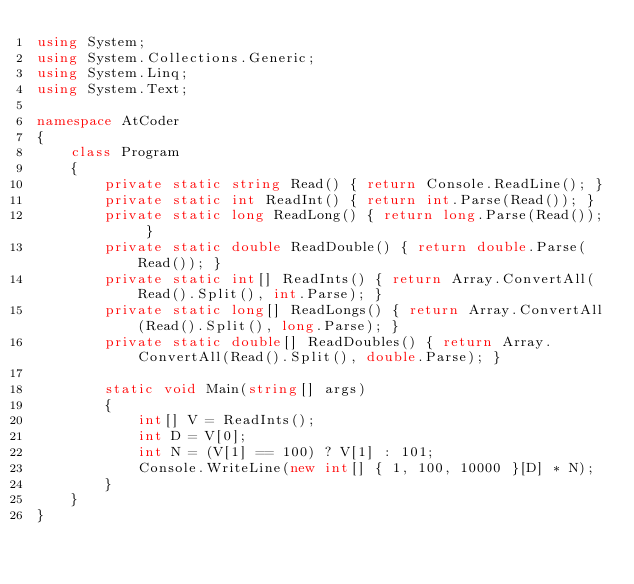Convert code to text. <code><loc_0><loc_0><loc_500><loc_500><_C#_>using System;
using System.Collections.Generic;
using System.Linq;
using System.Text;

namespace AtCoder
{
    class Program
    {
        private static string Read() { return Console.ReadLine(); }
        private static int ReadInt() { return int.Parse(Read()); }
        private static long ReadLong() { return long.Parse(Read()); }
        private static double ReadDouble() { return double.Parse(Read()); }
        private static int[] ReadInts() { return Array.ConvertAll(Read().Split(), int.Parse); }
        private static long[] ReadLongs() { return Array.ConvertAll(Read().Split(), long.Parse); }
        private static double[] ReadDoubles() { return Array.ConvertAll(Read().Split(), double.Parse); }

        static void Main(string[] args)
        {
            int[] V = ReadInts();
            int D = V[0];
            int N = (V[1] == 100) ? V[1] : 101;
            Console.WriteLine(new int[] { 1, 100, 10000 }[D] * N);
        }
    }
}</code> 